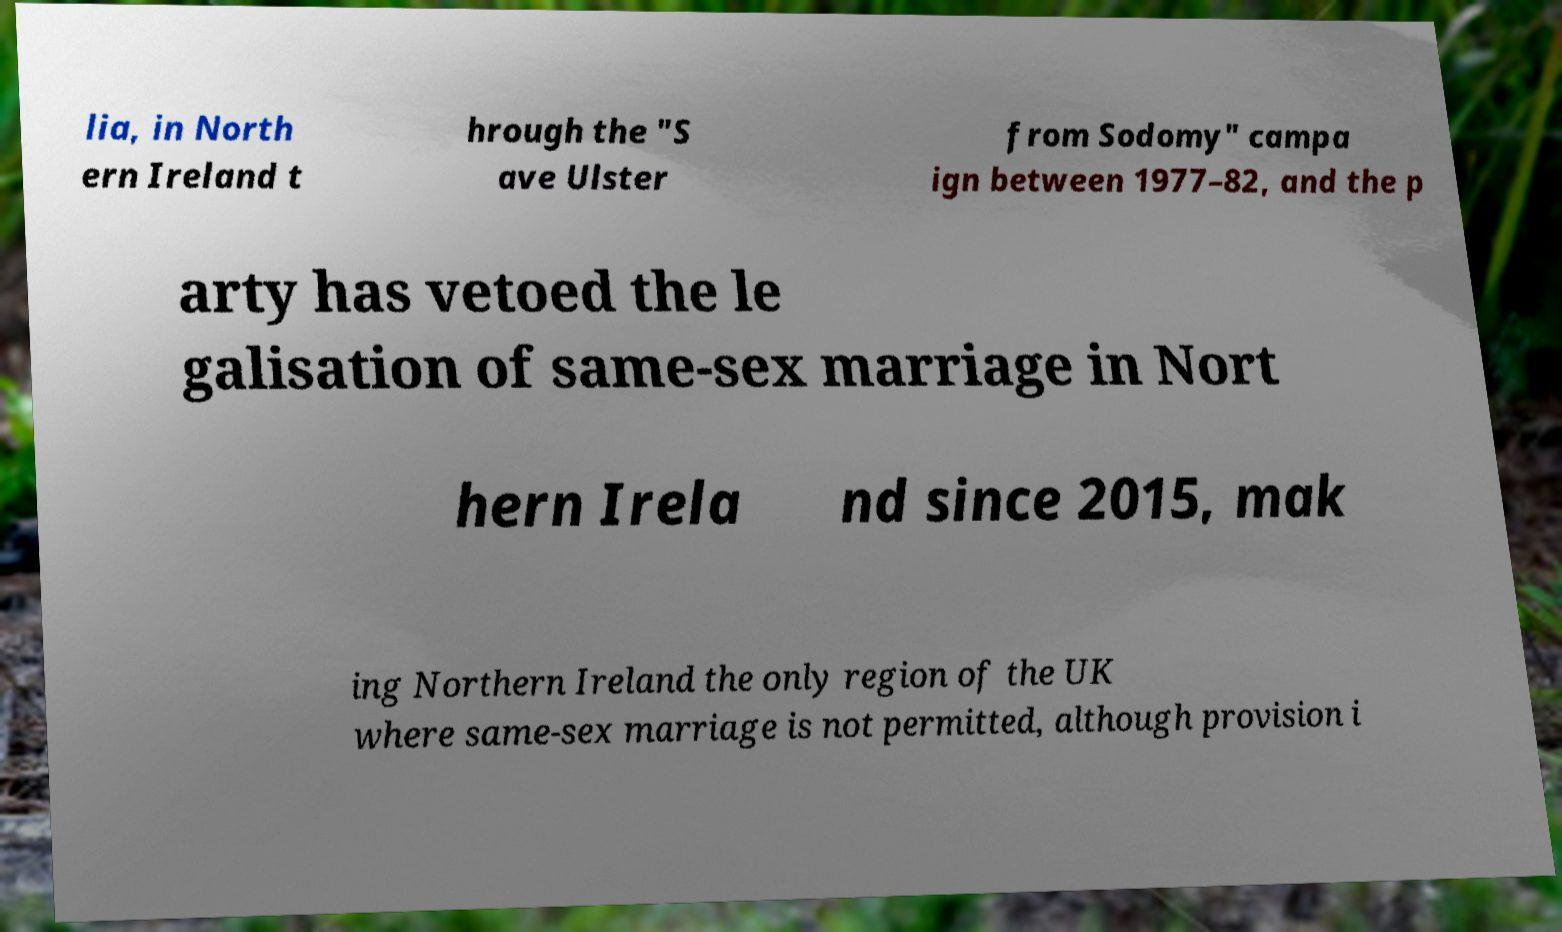For documentation purposes, I need the text within this image transcribed. Could you provide that? lia, in North ern Ireland t hrough the "S ave Ulster from Sodomy" campa ign between 1977–82, and the p arty has vetoed the le galisation of same-sex marriage in Nort hern Irela nd since 2015, mak ing Northern Ireland the only region of the UK where same-sex marriage is not permitted, although provision i 